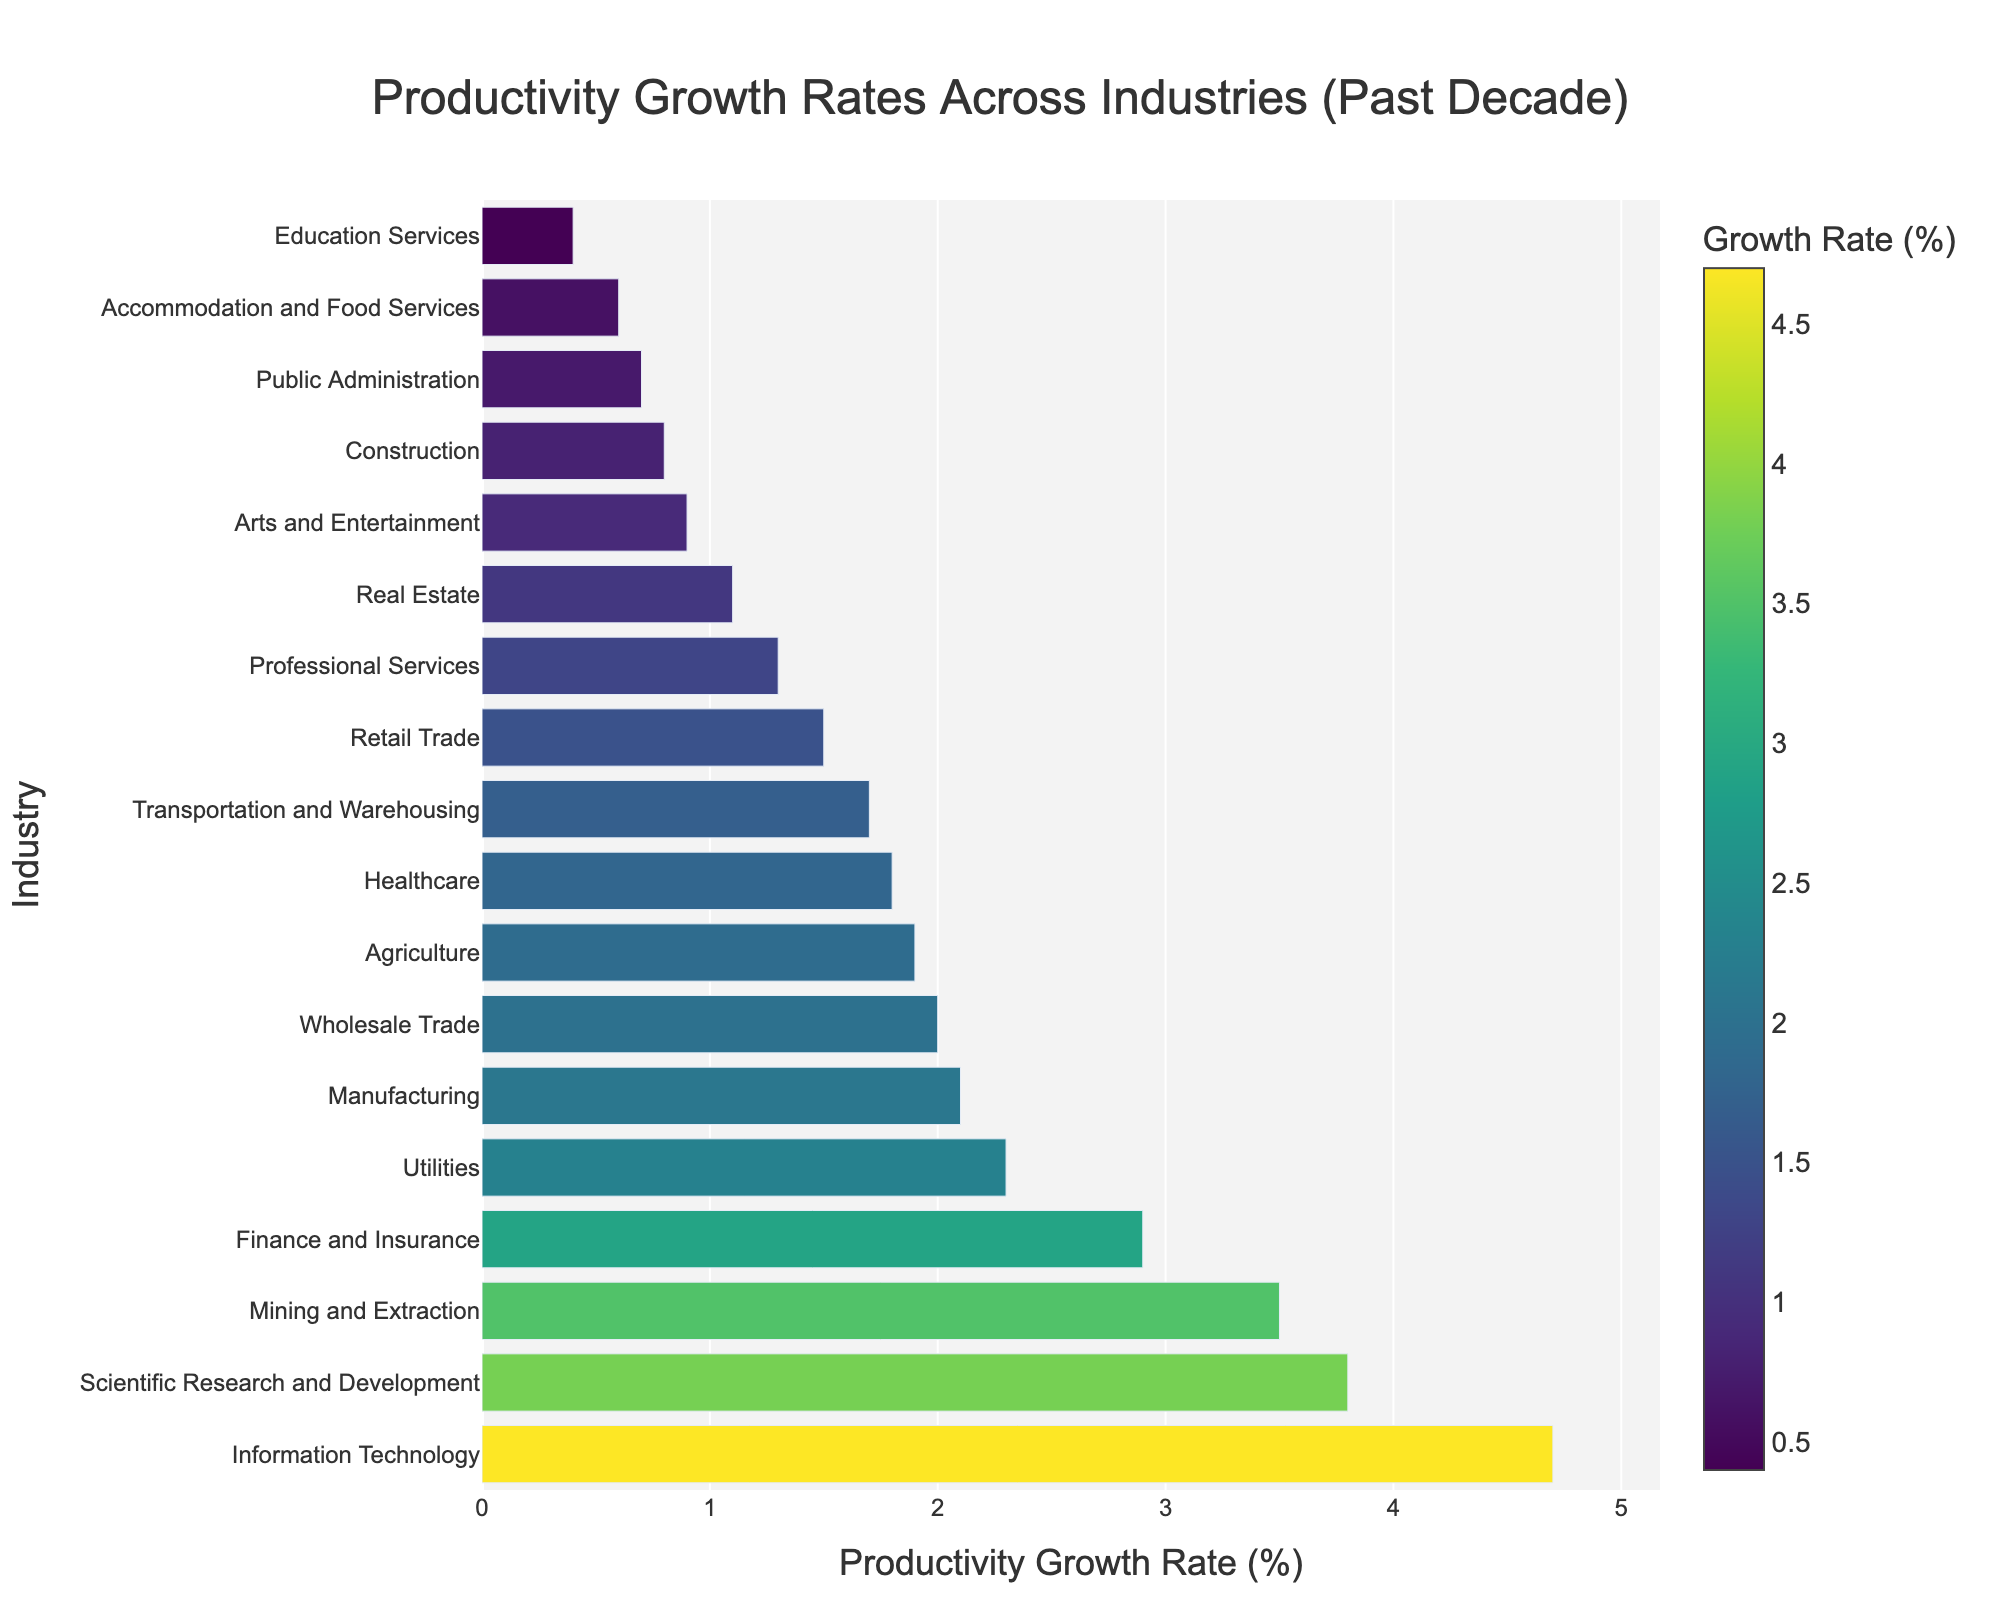what is the highest productivity growth rate in the chart? The highest productivity growth rate can be identified by looking at the longest bar in the chart, which represents the Information Technology industry with a growth rate of 4.7%.
Answer: 4.7% which industry has the lowest productivity growth rate? The shortest bar in the chart represents the industry with the lowest productivity growth rate which is Education Services with a rate of 0.4%.
Answer: Education Services how much higher is the productivity growth rate for Information Technology compared to Construction? The productivity growth rate for Information Technology is 4.7%, while for Construction it is 0.8%. Subtracting these values gives 4.7% - 0.8% = 3.9%.
Answer: 3.9% which industries have productivity growth rates higher than 3%? The industries with bars extending beyond the 3% mark are Information Technology, Scientific Research and Development, and Mining and Extraction. Their rates are 4.7%, 3.8%, and 3.5% respectively.
Answer: Information Technology, Scientific Research and Development, Mining and Extraction what is the average productivity growth rate of the top 3 industries? The top 3 industries by productivity growth rate are Information Technology (4.7%), Scientific Research and Development (3.8%), and Mining and Extraction (3.5%). The sum of their rates is 4.7 + 3.8 + 3.5 = 12.0 and the average is 12.0 / 3 = 4.0.
Answer: 4.0 how does the productivity growth rate of Utilities compare with Manufacturing? The productivity growth rate for Utilities is 2.3% and for Manufacturing, it is 2.1%. Utilities have a higher rate by 2.3% - 2.1% = 0.2%.
Answer: Utilities is higher by 0.2% what is the combined productivity growth rate of Healthcare and Transportation and Warehousing? The productivity growth rate for Healthcare is 1.8% and for Transportation and Warehousing it is 1.7%. Combined, they sum to 1.8% + 1.7% = 3.5%.
Answer: 3.5% which industries fall below the median productivity growth rate? To find the median, we first sort all 17 industries by their productivity growth rates. The middle value, or the 9th industry, is Finance and Insurance at 2.9%. Industries below this rate are Manufacturing, Healthcare, Transportation and Warehousing, Retail Trade, Agriculture, Real Estate, Professional Services, Arts and Entertainment, Construction, Accommodation and Food Services, Public Administration, and Education Services.
Answer: Manufacturing, Healthcare, Transportation and Warehousing, Retail Trade, Agriculture, Real Estate, Professional Services, Arts and Entertainment, Construction, Accommodation and Food Services, Public Administration, Education Services 